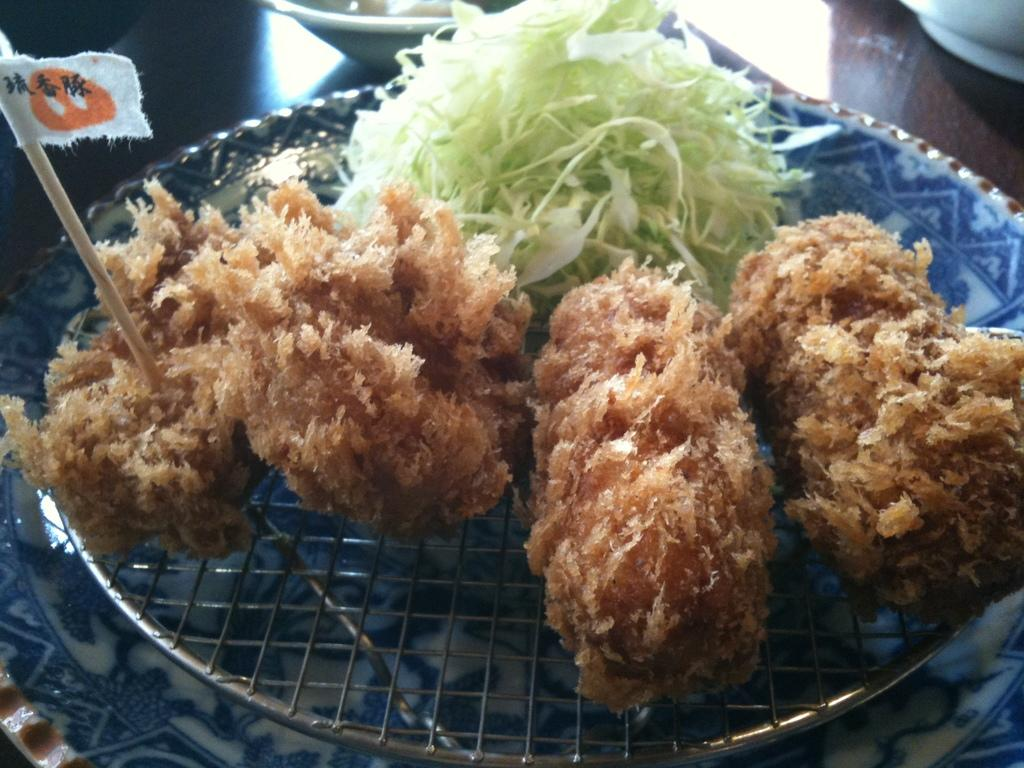What type of food item can be seen in the image? There is a food item in the image, which is chopped cabbage. Can you describe the appearance of the food item? The food item is chopped cabbage, which appears to be in small, uniform pieces. What question is being asked in the image? There is no question being asked in the image; it only shows chopped cabbage. 